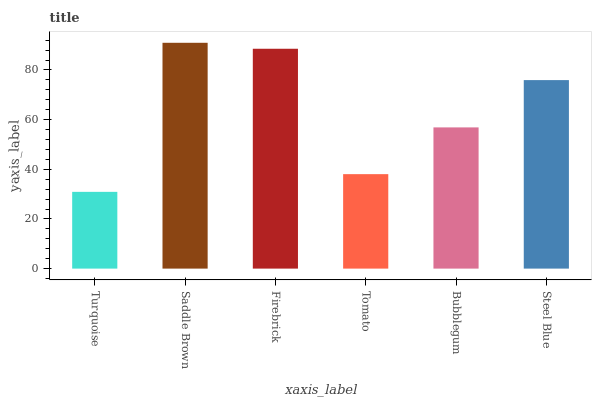Is Turquoise the minimum?
Answer yes or no. Yes. Is Saddle Brown the maximum?
Answer yes or no. Yes. Is Firebrick the minimum?
Answer yes or no. No. Is Firebrick the maximum?
Answer yes or no. No. Is Saddle Brown greater than Firebrick?
Answer yes or no. Yes. Is Firebrick less than Saddle Brown?
Answer yes or no. Yes. Is Firebrick greater than Saddle Brown?
Answer yes or no. No. Is Saddle Brown less than Firebrick?
Answer yes or no. No. Is Steel Blue the high median?
Answer yes or no. Yes. Is Bubblegum the low median?
Answer yes or no. Yes. Is Firebrick the high median?
Answer yes or no. No. Is Steel Blue the low median?
Answer yes or no. No. 